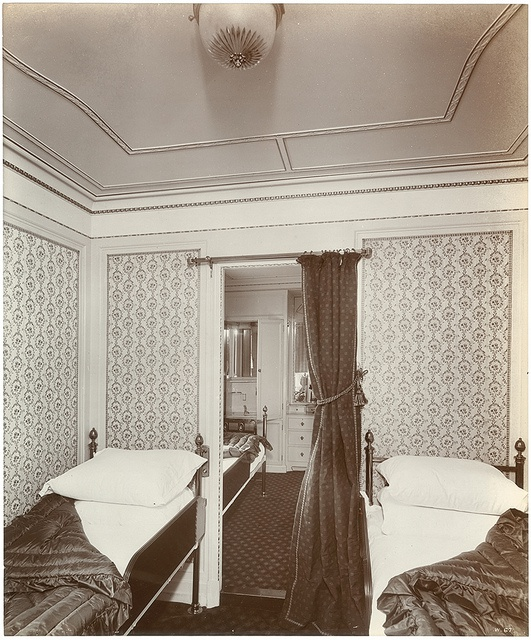Describe the objects in this image and their specific colors. I can see bed in white, lightgray, gray, black, and maroon tones, bed in white, lightgray, gray, and maroon tones, and bed in white, maroon, gray, and beige tones in this image. 